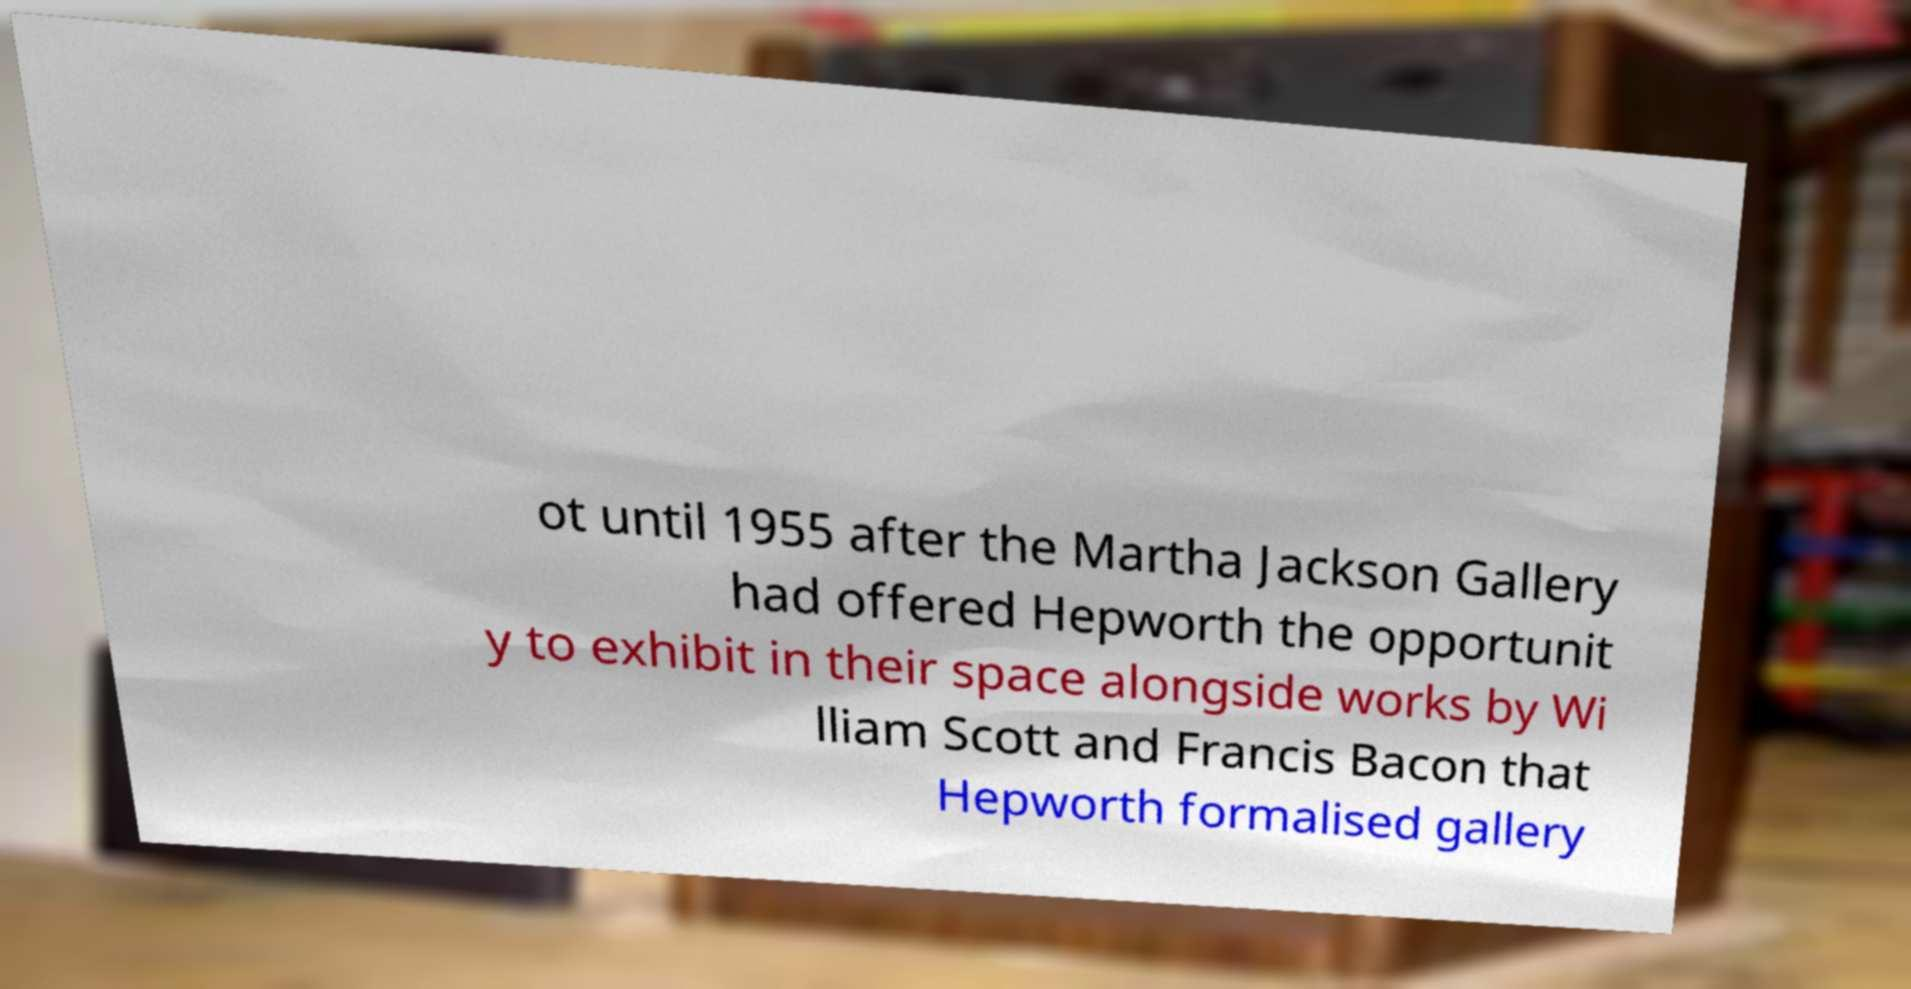Please read and relay the text visible in this image. What does it say? ot until 1955 after the Martha Jackson Gallery had offered Hepworth the opportunit y to exhibit in their space alongside works by Wi lliam Scott and Francis Bacon that Hepworth formalised gallery 